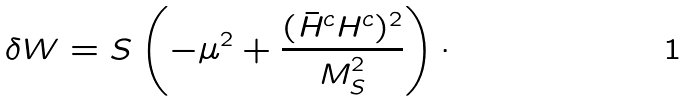Convert formula to latex. <formula><loc_0><loc_0><loc_500><loc_500>\delta W = S \left ( - \mu ^ { 2 } + \frac { ( \bar { H } ^ { c } H ^ { c } ) ^ { 2 } } { M _ { S } ^ { 2 } } \right ) \cdot</formula> 